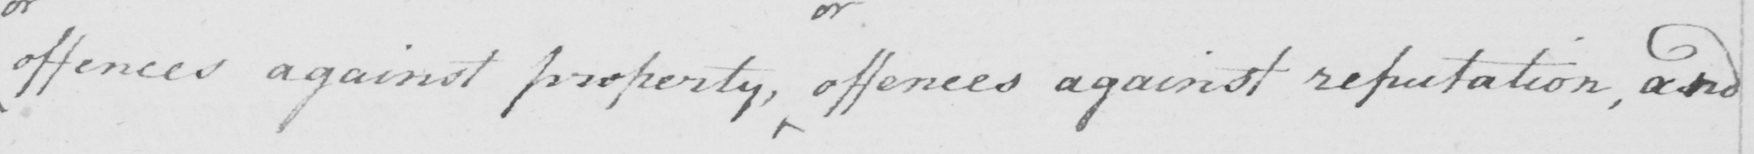What does this handwritten line say? offences against property, offences against reputation, and 